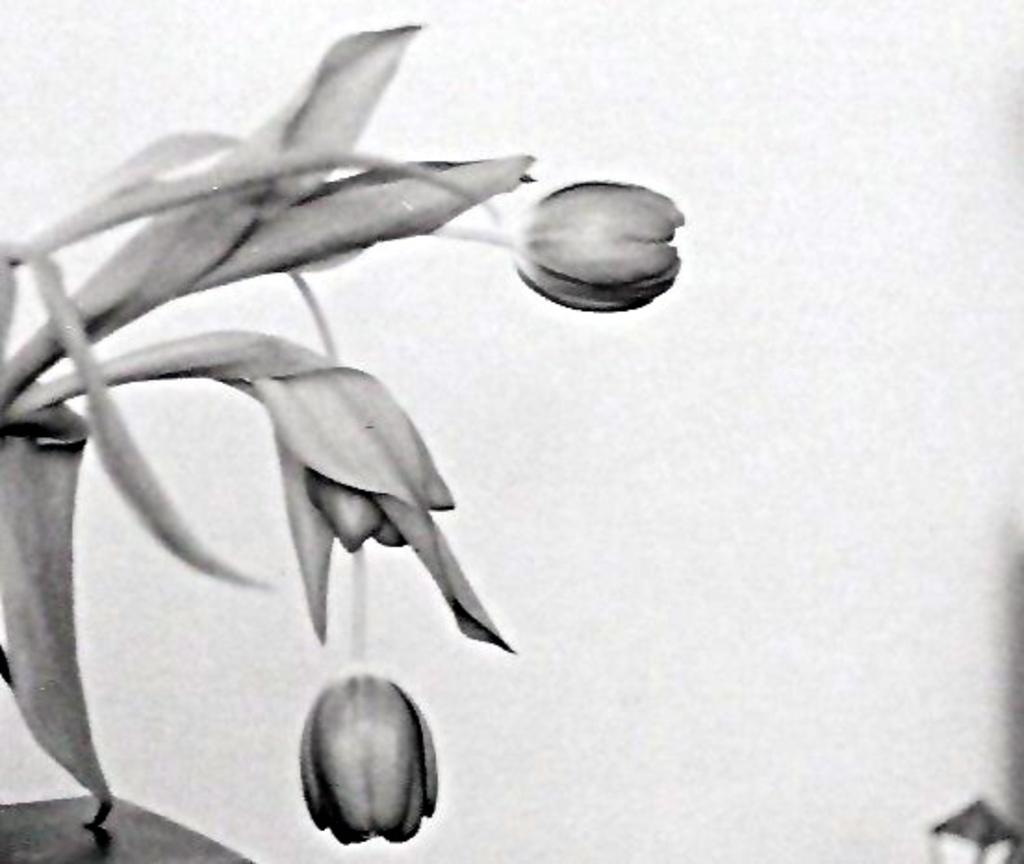What types of plants are depicted in the image? The image contains depictions of flowers and leaves. What color scheme is used in the image? The image is black and white in color. What type of doctor is depicted in the image? There is no doctor depicted in the image; it contains depictions of flowers and leaves. What boundary is shown in the image? There is no boundary present in the image; it features black and white depictions of flowers and leaves. 